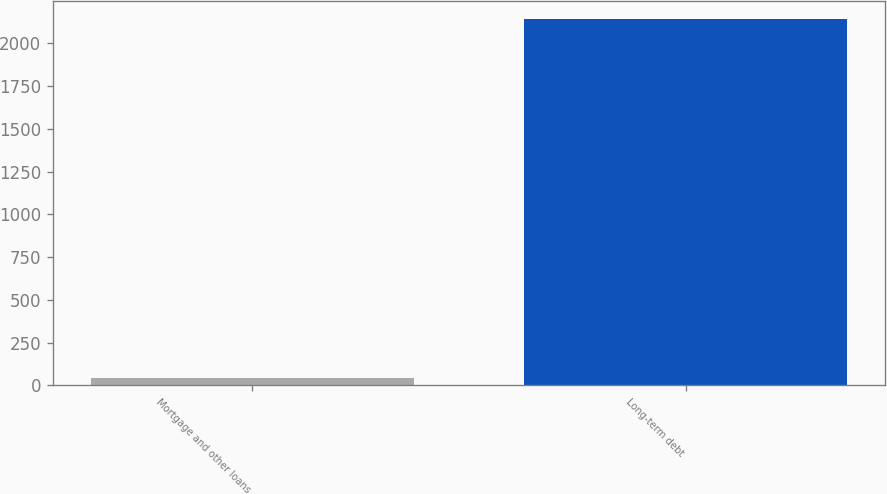Convert chart. <chart><loc_0><loc_0><loc_500><loc_500><bar_chart><fcel>Mortgage and other loans<fcel>Long-term debt<nl><fcel>43<fcel>2142<nl></chart> 